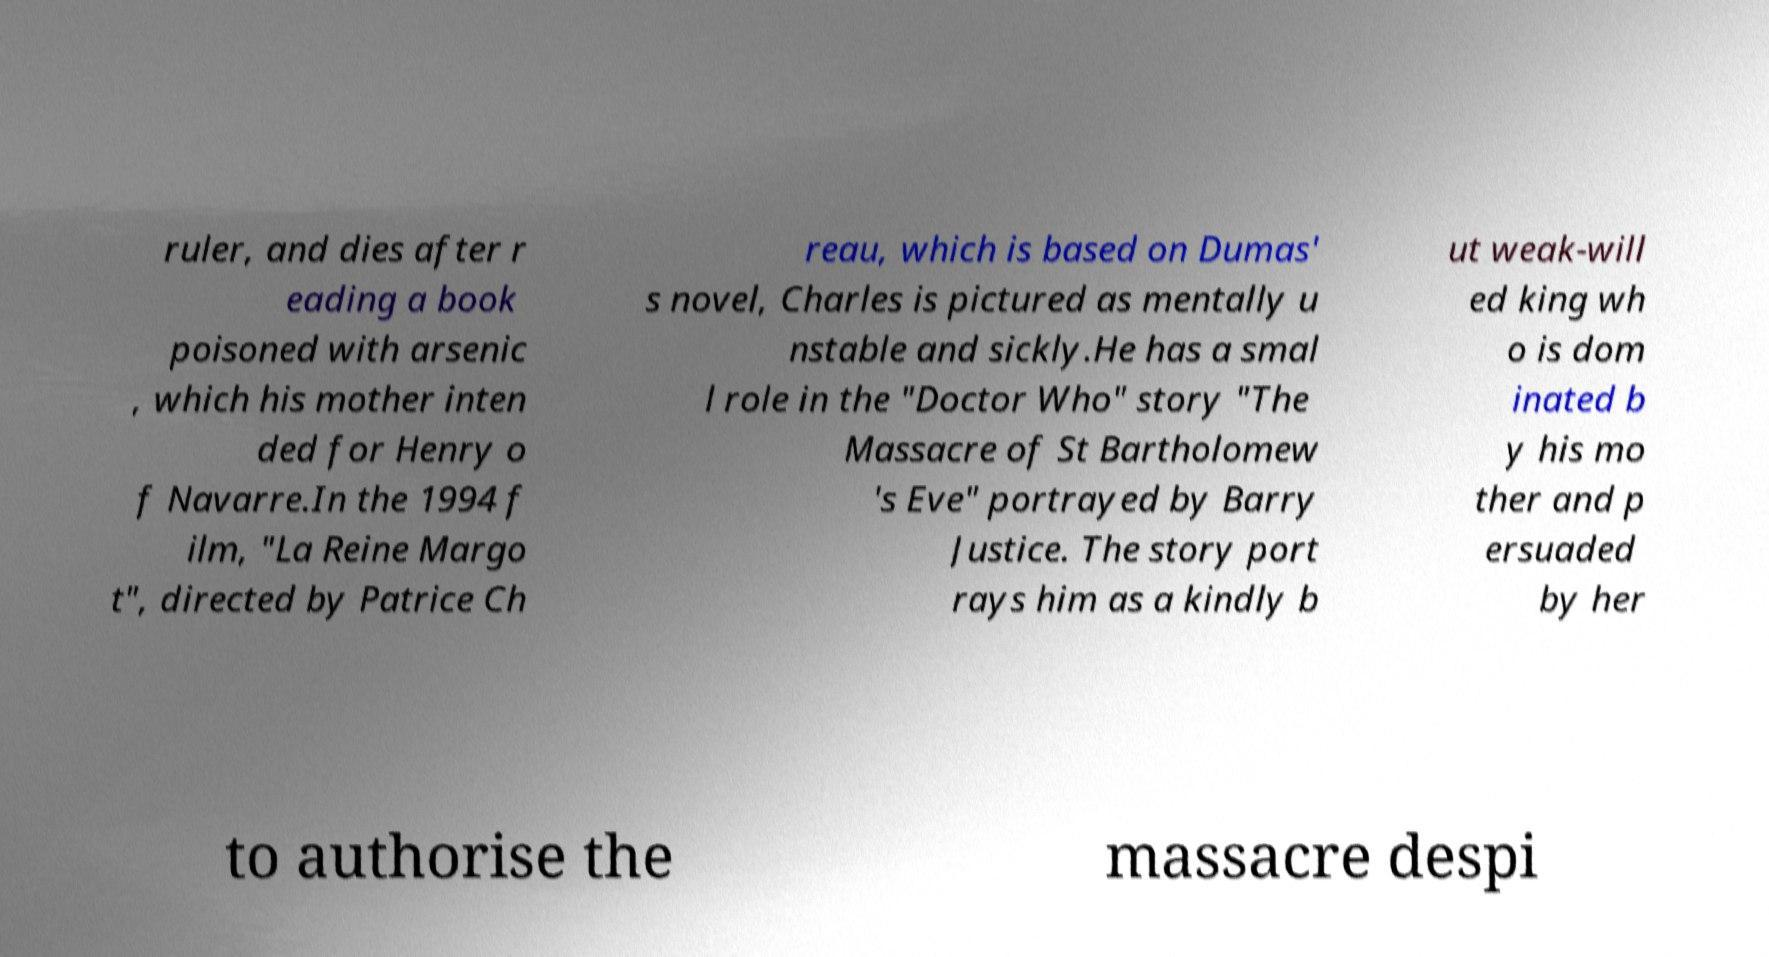Could you assist in decoding the text presented in this image and type it out clearly? ruler, and dies after r eading a book poisoned with arsenic , which his mother inten ded for Henry o f Navarre.In the 1994 f ilm, "La Reine Margo t", directed by Patrice Ch reau, which is based on Dumas' s novel, Charles is pictured as mentally u nstable and sickly.He has a smal l role in the "Doctor Who" story "The Massacre of St Bartholomew 's Eve" portrayed by Barry Justice. The story port rays him as a kindly b ut weak-will ed king wh o is dom inated b y his mo ther and p ersuaded by her to authorise the massacre despi 